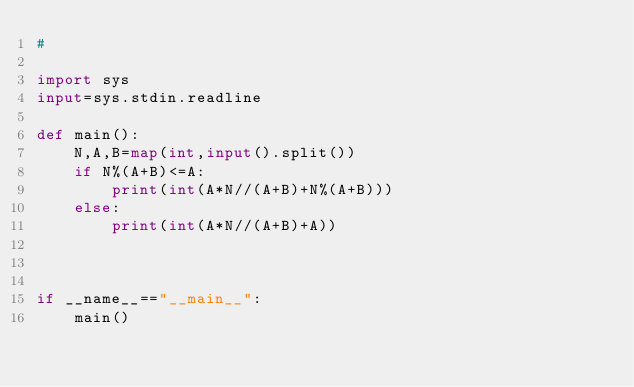<code> <loc_0><loc_0><loc_500><loc_500><_Python_>#

import sys
input=sys.stdin.readline

def main():
    N,A,B=map(int,input().split())
    if N%(A+B)<=A:
        print(int(A*N//(A+B)+N%(A+B)))
    else:
        print(int(A*N//(A+B)+A))
    
    
    
if __name__=="__main__":
    main()
</code> 